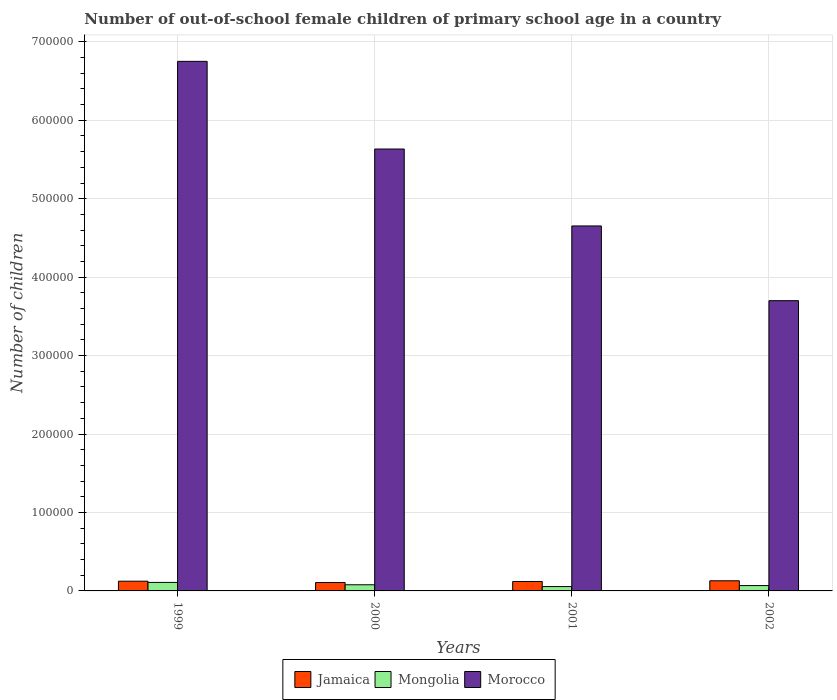How many different coloured bars are there?
Your answer should be very brief. 3. How many groups of bars are there?
Keep it short and to the point. 4. Are the number of bars per tick equal to the number of legend labels?
Ensure brevity in your answer.  Yes. Are the number of bars on each tick of the X-axis equal?
Your answer should be compact. Yes. How many bars are there on the 4th tick from the left?
Your answer should be compact. 3. What is the label of the 3rd group of bars from the left?
Your answer should be compact. 2001. In how many cases, is the number of bars for a given year not equal to the number of legend labels?
Your response must be concise. 0. What is the number of out-of-school female children in Mongolia in 2001?
Provide a short and direct response. 5553. Across all years, what is the maximum number of out-of-school female children in Mongolia?
Keep it short and to the point. 1.08e+04. Across all years, what is the minimum number of out-of-school female children in Jamaica?
Ensure brevity in your answer.  1.07e+04. In which year was the number of out-of-school female children in Jamaica maximum?
Your answer should be compact. 2002. In which year was the number of out-of-school female children in Morocco minimum?
Ensure brevity in your answer.  2002. What is the total number of out-of-school female children in Jamaica in the graph?
Provide a succinct answer. 4.80e+04. What is the difference between the number of out-of-school female children in Mongolia in 1999 and that in 2001?
Provide a short and direct response. 5297. What is the difference between the number of out-of-school female children in Jamaica in 2001 and the number of out-of-school female children in Morocco in 1999?
Offer a very short reply. -6.63e+05. What is the average number of out-of-school female children in Mongolia per year?
Your answer should be compact. 7766.25. In the year 2000, what is the difference between the number of out-of-school female children in Mongolia and number of out-of-school female children in Morocco?
Ensure brevity in your answer.  -5.55e+05. In how many years, is the number of out-of-school female children in Morocco greater than 420000?
Offer a very short reply. 3. What is the ratio of the number of out-of-school female children in Mongolia in 2000 to that in 2001?
Your answer should be very brief. 1.41. Is the number of out-of-school female children in Jamaica in 1999 less than that in 2000?
Your answer should be very brief. No. Is the difference between the number of out-of-school female children in Mongolia in 1999 and 2000 greater than the difference between the number of out-of-school female children in Morocco in 1999 and 2000?
Your response must be concise. No. What is the difference between the highest and the second highest number of out-of-school female children in Morocco?
Provide a succinct answer. 1.12e+05. What is the difference between the highest and the lowest number of out-of-school female children in Jamaica?
Offer a very short reply. 2220. In how many years, is the number of out-of-school female children in Mongolia greater than the average number of out-of-school female children in Mongolia taken over all years?
Your answer should be very brief. 2. Is the sum of the number of out-of-school female children in Jamaica in 1999 and 2002 greater than the maximum number of out-of-school female children in Mongolia across all years?
Provide a short and direct response. Yes. What does the 2nd bar from the left in 2002 represents?
Keep it short and to the point. Mongolia. What does the 3rd bar from the right in 2001 represents?
Ensure brevity in your answer.  Jamaica. How many bars are there?
Offer a terse response. 12. Are all the bars in the graph horizontal?
Ensure brevity in your answer.  No. How many years are there in the graph?
Make the answer very short. 4. What is the difference between two consecutive major ticks on the Y-axis?
Give a very brief answer. 1.00e+05. Are the values on the major ticks of Y-axis written in scientific E-notation?
Provide a succinct answer. No. Does the graph contain any zero values?
Provide a short and direct response. No. Does the graph contain grids?
Ensure brevity in your answer.  Yes. How many legend labels are there?
Provide a succinct answer. 3. What is the title of the graph?
Offer a very short reply. Number of out-of-school female children of primary school age in a country. What is the label or title of the Y-axis?
Make the answer very short. Number of children. What is the Number of children in Jamaica in 1999?
Offer a terse response. 1.24e+04. What is the Number of children of Mongolia in 1999?
Ensure brevity in your answer.  1.08e+04. What is the Number of children in Morocco in 1999?
Offer a very short reply. 6.75e+05. What is the Number of children in Jamaica in 2000?
Keep it short and to the point. 1.07e+04. What is the Number of children of Mongolia in 2000?
Give a very brief answer. 7839. What is the Number of children of Morocco in 2000?
Your response must be concise. 5.63e+05. What is the Number of children in Jamaica in 2001?
Your answer should be very brief. 1.20e+04. What is the Number of children of Mongolia in 2001?
Ensure brevity in your answer.  5553. What is the Number of children of Morocco in 2001?
Provide a succinct answer. 4.65e+05. What is the Number of children of Jamaica in 2002?
Your answer should be very brief. 1.29e+04. What is the Number of children in Mongolia in 2002?
Keep it short and to the point. 6823. What is the Number of children in Morocco in 2002?
Your response must be concise. 3.70e+05. Across all years, what is the maximum Number of children in Jamaica?
Offer a very short reply. 1.29e+04. Across all years, what is the maximum Number of children of Mongolia?
Your answer should be very brief. 1.08e+04. Across all years, what is the maximum Number of children of Morocco?
Give a very brief answer. 6.75e+05. Across all years, what is the minimum Number of children of Jamaica?
Your answer should be very brief. 1.07e+04. Across all years, what is the minimum Number of children in Mongolia?
Your answer should be very brief. 5553. Across all years, what is the minimum Number of children of Morocco?
Make the answer very short. 3.70e+05. What is the total Number of children of Jamaica in the graph?
Keep it short and to the point. 4.80e+04. What is the total Number of children in Mongolia in the graph?
Your answer should be compact. 3.11e+04. What is the total Number of children of Morocco in the graph?
Your answer should be very brief. 2.07e+06. What is the difference between the Number of children in Jamaica in 1999 and that in 2000?
Give a very brief answer. 1700. What is the difference between the Number of children in Mongolia in 1999 and that in 2000?
Give a very brief answer. 3011. What is the difference between the Number of children of Morocco in 1999 and that in 2000?
Keep it short and to the point. 1.12e+05. What is the difference between the Number of children of Jamaica in 1999 and that in 2001?
Give a very brief answer. 384. What is the difference between the Number of children in Mongolia in 1999 and that in 2001?
Offer a very short reply. 5297. What is the difference between the Number of children of Morocco in 1999 and that in 2001?
Offer a terse response. 2.10e+05. What is the difference between the Number of children of Jamaica in 1999 and that in 2002?
Your answer should be compact. -520. What is the difference between the Number of children in Mongolia in 1999 and that in 2002?
Offer a terse response. 4027. What is the difference between the Number of children in Morocco in 1999 and that in 2002?
Your answer should be compact. 3.05e+05. What is the difference between the Number of children in Jamaica in 2000 and that in 2001?
Provide a short and direct response. -1316. What is the difference between the Number of children in Mongolia in 2000 and that in 2001?
Your answer should be compact. 2286. What is the difference between the Number of children in Morocco in 2000 and that in 2001?
Offer a terse response. 9.81e+04. What is the difference between the Number of children of Jamaica in 2000 and that in 2002?
Your answer should be compact. -2220. What is the difference between the Number of children in Mongolia in 2000 and that in 2002?
Your answer should be compact. 1016. What is the difference between the Number of children in Morocco in 2000 and that in 2002?
Your response must be concise. 1.93e+05. What is the difference between the Number of children in Jamaica in 2001 and that in 2002?
Provide a succinct answer. -904. What is the difference between the Number of children of Mongolia in 2001 and that in 2002?
Offer a terse response. -1270. What is the difference between the Number of children of Morocco in 2001 and that in 2002?
Provide a succinct answer. 9.53e+04. What is the difference between the Number of children in Jamaica in 1999 and the Number of children in Mongolia in 2000?
Your answer should be very brief. 4558. What is the difference between the Number of children in Jamaica in 1999 and the Number of children in Morocco in 2000?
Make the answer very short. -5.51e+05. What is the difference between the Number of children in Mongolia in 1999 and the Number of children in Morocco in 2000?
Give a very brief answer. -5.52e+05. What is the difference between the Number of children in Jamaica in 1999 and the Number of children in Mongolia in 2001?
Provide a short and direct response. 6844. What is the difference between the Number of children in Jamaica in 1999 and the Number of children in Morocco in 2001?
Offer a terse response. -4.53e+05. What is the difference between the Number of children of Mongolia in 1999 and the Number of children of Morocco in 2001?
Provide a short and direct response. -4.54e+05. What is the difference between the Number of children in Jamaica in 1999 and the Number of children in Mongolia in 2002?
Your answer should be compact. 5574. What is the difference between the Number of children of Jamaica in 1999 and the Number of children of Morocco in 2002?
Ensure brevity in your answer.  -3.58e+05. What is the difference between the Number of children in Mongolia in 1999 and the Number of children in Morocco in 2002?
Provide a succinct answer. -3.59e+05. What is the difference between the Number of children of Jamaica in 2000 and the Number of children of Mongolia in 2001?
Offer a terse response. 5144. What is the difference between the Number of children of Jamaica in 2000 and the Number of children of Morocco in 2001?
Keep it short and to the point. -4.55e+05. What is the difference between the Number of children in Mongolia in 2000 and the Number of children in Morocco in 2001?
Make the answer very short. -4.57e+05. What is the difference between the Number of children in Jamaica in 2000 and the Number of children in Mongolia in 2002?
Your answer should be compact. 3874. What is the difference between the Number of children of Jamaica in 2000 and the Number of children of Morocco in 2002?
Offer a very short reply. -3.59e+05. What is the difference between the Number of children in Mongolia in 2000 and the Number of children in Morocco in 2002?
Make the answer very short. -3.62e+05. What is the difference between the Number of children of Jamaica in 2001 and the Number of children of Mongolia in 2002?
Ensure brevity in your answer.  5190. What is the difference between the Number of children in Jamaica in 2001 and the Number of children in Morocco in 2002?
Offer a terse response. -3.58e+05. What is the difference between the Number of children in Mongolia in 2001 and the Number of children in Morocco in 2002?
Provide a succinct answer. -3.64e+05. What is the average Number of children in Jamaica per year?
Provide a short and direct response. 1.20e+04. What is the average Number of children of Mongolia per year?
Make the answer very short. 7766.25. What is the average Number of children in Morocco per year?
Your answer should be very brief. 5.18e+05. In the year 1999, what is the difference between the Number of children in Jamaica and Number of children in Mongolia?
Your response must be concise. 1547. In the year 1999, what is the difference between the Number of children of Jamaica and Number of children of Morocco?
Your response must be concise. -6.63e+05. In the year 1999, what is the difference between the Number of children in Mongolia and Number of children in Morocco?
Your answer should be compact. -6.64e+05. In the year 2000, what is the difference between the Number of children in Jamaica and Number of children in Mongolia?
Keep it short and to the point. 2858. In the year 2000, what is the difference between the Number of children in Jamaica and Number of children in Morocco?
Offer a terse response. -5.53e+05. In the year 2000, what is the difference between the Number of children of Mongolia and Number of children of Morocco?
Your answer should be very brief. -5.55e+05. In the year 2001, what is the difference between the Number of children of Jamaica and Number of children of Mongolia?
Make the answer very short. 6460. In the year 2001, what is the difference between the Number of children in Jamaica and Number of children in Morocco?
Provide a succinct answer. -4.53e+05. In the year 2001, what is the difference between the Number of children of Mongolia and Number of children of Morocco?
Your answer should be very brief. -4.60e+05. In the year 2002, what is the difference between the Number of children in Jamaica and Number of children in Mongolia?
Ensure brevity in your answer.  6094. In the year 2002, what is the difference between the Number of children in Jamaica and Number of children in Morocco?
Ensure brevity in your answer.  -3.57e+05. In the year 2002, what is the difference between the Number of children in Mongolia and Number of children in Morocco?
Keep it short and to the point. -3.63e+05. What is the ratio of the Number of children of Jamaica in 1999 to that in 2000?
Provide a succinct answer. 1.16. What is the ratio of the Number of children of Mongolia in 1999 to that in 2000?
Keep it short and to the point. 1.38. What is the ratio of the Number of children of Morocco in 1999 to that in 2000?
Your answer should be very brief. 1.2. What is the ratio of the Number of children in Jamaica in 1999 to that in 2001?
Provide a succinct answer. 1.03. What is the ratio of the Number of children in Mongolia in 1999 to that in 2001?
Provide a succinct answer. 1.95. What is the ratio of the Number of children of Morocco in 1999 to that in 2001?
Ensure brevity in your answer.  1.45. What is the ratio of the Number of children of Jamaica in 1999 to that in 2002?
Your answer should be compact. 0.96. What is the ratio of the Number of children in Mongolia in 1999 to that in 2002?
Your answer should be compact. 1.59. What is the ratio of the Number of children of Morocco in 1999 to that in 2002?
Ensure brevity in your answer.  1.82. What is the ratio of the Number of children in Jamaica in 2000 to that in 2001?
Make the answer very short. 0.89. What is the ratio of the Number of children of Mongolia in 2000 to that in 2001?
Ensure brevity in your answer.  1.41. What is the ratio of the Number of children in Morocco in 2000 to that in 2001?
Your answer should be very brief. 1.21. What is the ratio of the Number of children in Jamaica in 2000 to that in 2002?
Provide a succinct answer. 0.83. What is the ratio of the Number of children of Mongolia in 2000 to that in 2002?
Keep it short and to the point. 1.15. What is the ratio of the Number of children in Morocco in 2000 to that in 2002?
Provide a short and direct response. 1.52. What is the ratio of the Number of children in Jamaica in 2001 to that in 2002?
Provide a short and direct response. 0.93. What is the ratio of the Number of children of Mongolia in 2001 to that in 2002?
Give a very brief answer. 0.81. What is the ratio of the Number of children of Morocco in 2001 to that in 2002?
Your answer should be compact. 1.26. What is the difference between the highest and the second highest Number of children in Jamaica?
Your response must be concise. 520. What is the difference between the highest and the second highest Number of children of Mongolia?
Ensure brevity in your answer.  3011. What is the difference between the highest and the second highest Number of children in Morocco?
Offer a terse response. 1.12e+05. What is the difference between the highest and the lowest Number of children of Jamaica?
Provide a short and direct response. 2220. What is the difference between the highest and the lowest Number of children of Mongolia?
Your answer should be very brief. 5297. What is the difference between the highest and the lowest Number of children in Morocco?
Your answer should be compact. 3.05e+05. 